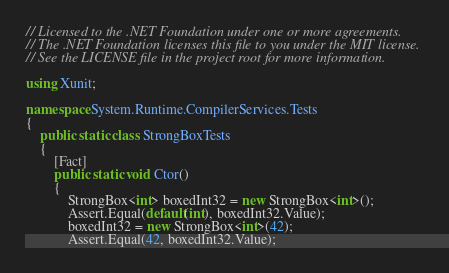<code> <loc_0><loc_0><loc_500><loc_500><_C#_>// Licensed to the .NET Foundation under one or more agreements.
// The .NET Foundation licenses this file to you under the MIT license.
// See the LICENSE file in the project root for more information.

using Xunit;

namespace System.Runtime.CompilerServices.Tests
{
    public static class StrongBoxTests
    {
        [Fact]
        public static void Ctor()
        {
            StrongBox<int> boxedInt32 = new StrongBox<int>();
            Assert.Equal(default(int), boxedInt32.Value);
            boxedInt32 = new StrongBox<int>(42);
            Assert.Equal(42, boxedInt32.Value);
</code> 